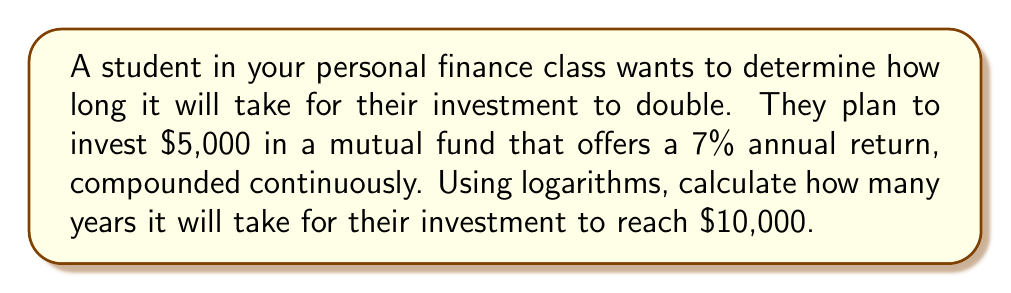What is the answer to this math problem? Let's approach this step-by-step using the continuous compound interest formula and logarithms:

1) The formula for continuous compound interest is:
   $A = P * e^{rt}$

   Where:
   $A$ = Final amount
   $P$ = Principal (initial investment)
   $e$ = Euler's number (approximately 2.71828)
   $r$ = Annual interest rate (as a decimal)
   $t$ = Time in years

2) We know:
   $P = 5000$
   $A = 10000$ (double the initial investment)
   $r = 0.07$ (7% as a decimal)

3) Let's substitute these into our formula:
   $10000 = 5000 * e^{0.07t}$

4) Divide both sides by 5000:
   $2 = e^{0.07t}$

5) Take the natural logarithm of both sides:
   $\ln(2) = \ln(e^{0.07t})$

6) Using the logarithm property $\ln(e^x) = x$:
   $\ln(2) = 0.07t$

7) Solve for $t$ by dividing both sides by 0.07:
   $t = \frac{\ln(2)}{0.07}$

8) Calculate the result:
   $t = \frac{0.693147...}{0.07} \approx 9.9021$ years

Therefore, it will take approximately 9.9 years for the investment to double.
Answer: $9.9$ years 